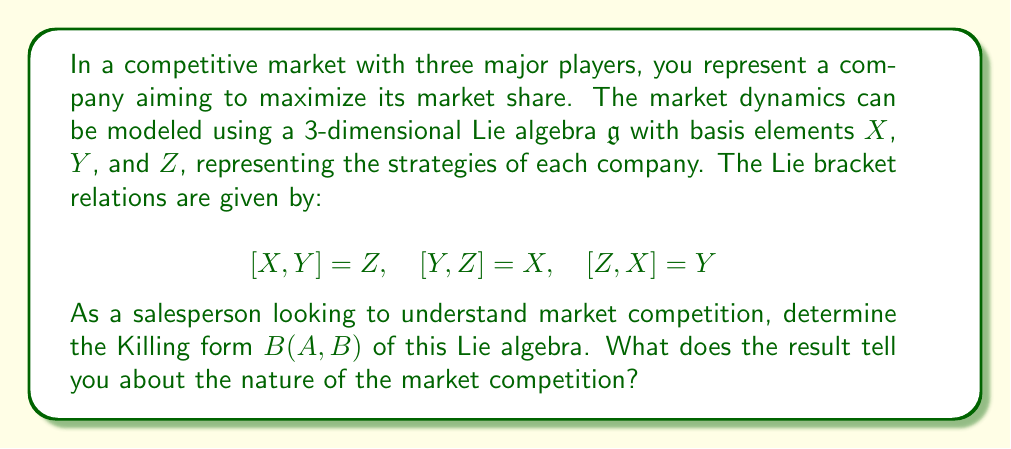Give your solution to this math problem. To find the Killing form of the given Lie algebra, we need to follow these steps:

1) The Killing form is defined as $B(A,B) = \text{tr}(\text{ad}(A) \circ \text{ad}(B))$, where $\text{ad}(A)$ is the adjoint representation of $A$.

2) First, let's calculate the adjoint representations of $X$, $Y$, and $Z$:

   $\text{ad}(X) = \begin{pmatrix} 0 & 0 & -1 \\ 0 & 0 & 1 \\ 0 & -1 & 0 \end{pmatrix}$

   $\text{ad}(Y) = \begin{pmatrix} 0 & 0 & 1 \\ 0 & 0 & -1 \\ -1 & 0 & 0 \end{pmatrix}$

   $\text{ad}(Z) = \begin{pmatrix} 0 & -1 & 0 \\ 1 & 0 & 0 \\ 0 & 0 & 0 \end{pmatrix}$

3) Now, we need to calculate $B(X,X)$, $B(Y,Y)$, $B(Z,Z)$, $B(X,Y)$, $B(Y,Z)$, and $B(X,Z)$:

   $B(X,X) = \text{tr}(\text{ad}(X) \circ \text{ad}(X)) = -2$
   $B(Y,Y) = \text{tr}(\text{ad}(Y) \circ \text{ad}(Y)) = -2$
   $B(Z,Z) = \text{tr}(\text{ad}(Z) \circ \text{ad}(Z)) = -2$
   $B(X,Y) = \text{tr}(\text{ad}(X) \circ \text{ad}(Y)) = 0$
   $B(Y,Z) = \text{tr}(\text{ad}(Y) \circ \text{ad}(Z)) = 0$
   $B(X,Z) = \text{tr}(\text{ad}(X) \circ \text{ad}(Z)) = 0$

4) Therefore, the Killing form can be represented as a matrix:

   $B = \begin{pmatrix} -2 & 0 & 0 \\ 0 & -2 & 0 \\ 0 & 0 & -2 \end{pmatrix}$

5) This Killing form is non-degenerate (its determinant is non-zero) and negative definite.

In terms of market competition, this result suggests:

a) The non-degeneracy indicates that the market strategies are fundamentally distinct and non-redundant.
b) The negative definiteness implies that the competition is stable and balanced, with no single strategy dominating the others.
c) The symmetry in the Killing form (-2 on the diagonal, 0 elsewhere) suggests that all three companies have equal influence in the market, and their strategies are equally effective.
Answer: The Killing form of the given Lie algebra is:

$$B = \begin{pmatrix} -2 & 0 & 0 \\ 0 & -2 & 0 \\ 0 & 0 & -2 \end{pmatrix}$$

This non-degenerate, negative definite Killing form indicates a stable, balanced market competition with three equally influential players. 